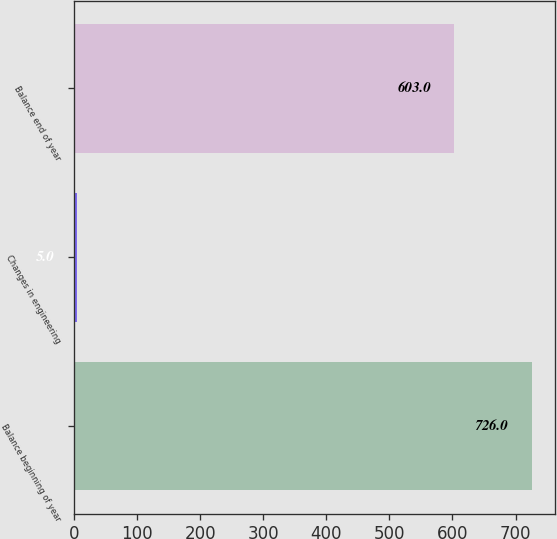Convert chart. <chart><loc_0><loc_0><loc_500><loc_500><bar_chart><fcel>Balance beginning of year<fcel>Changes in engineering<fcel>Balance end of year<nl><fcel>726<fcel>5<fcel>603<nl></chart> 